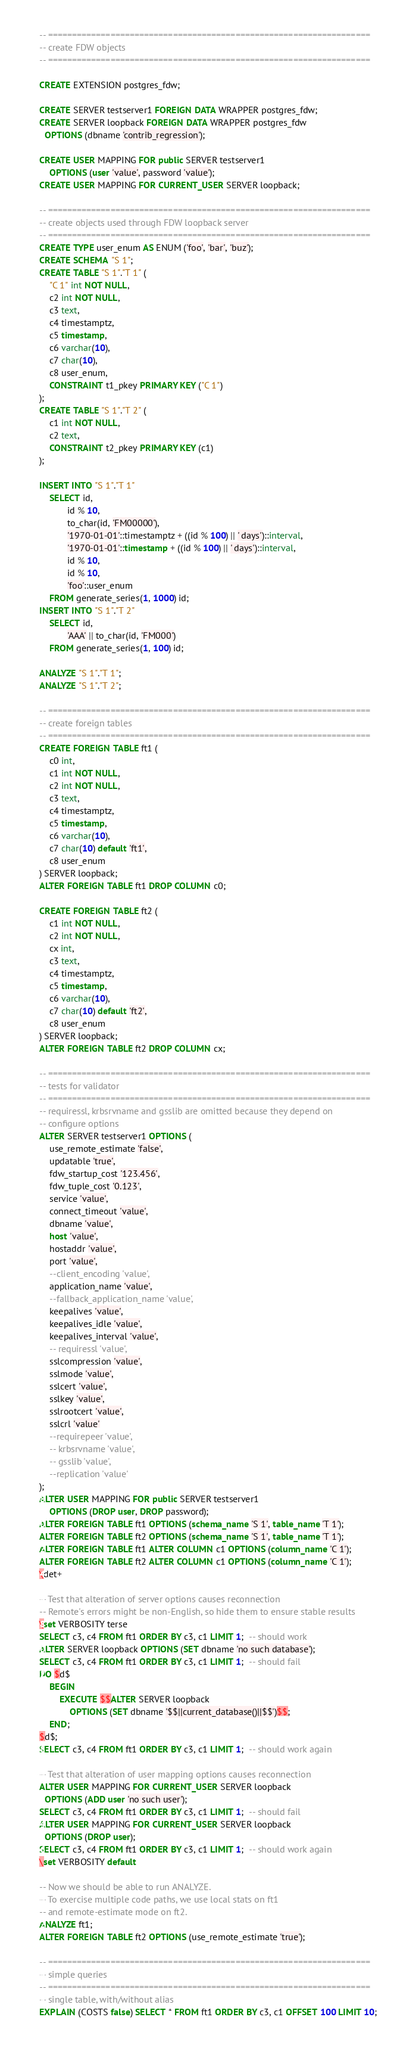Convert code to text. <code><loc_0><loc_0><loc_500><loc_500><_SQL_>-- ===================================================================
-- create FDW objects
-- ===================================================================

CREATE EXTENSION postgres_fdw;

CREATE SERVER testserver1 FOREIGN DATA WRAPPER postgres_fdw;
CREATE SERVER loopback FOREIGN DATA WRAPPER postgres_fdw
  OPTIONS (dbname 'contrib_regression');

CREATE USER MAPPING FOR public SERVER testserver1
	OPTIONS (user 'value', password 'value');
CREATE USER MAPPING FOR CURRENT_USER SERVER loopback;

-- ===================================================================
-- create objects used through FDW loopback server
-- ===================================================================
CREATE TYPE user_enum AS ENUM ('foo', 'bar', 'buz');
CREATE SCHEMA "S 1";
CREATE TABLE "S 1"."T 1" (
	"C 1" int NOT NULL,
	c2 int NOT NULL,
	c3 text,
	c4 timestamptz,
	c5 timestamp,
	c6 varchar(10),
	c7 char(10),
	c8 user_enum,
	CONSTRAINT t1_pkey PRIMARY KEY ("C 1")
);
CREATE TABLE "S 1"."T 2" (
	c1 int NOT NULL,
	c2 text,
	CONSTRAINT t2_pkey PRIMARY KEY (c1)
);

INSERT INTO "S 1"."T 1"
	SELECT id,
	       id % 10,
	       to_char(id, 'FM00000'),
	       '1970-01-01'::timestamptz + ((id % 100) || ' days')::interval,
	       '1970-01-01'::timestamp + ((id % 100) || ' days')::interval,
	       id % 10,
	       id % 10,
	       'foo'::user_enum
	FROM generate_series(1, 1000) id;
INSERT INTO "S 1"."T 2"
	SELECT id,
	       'AAA' || to_char(id, 'FM000')
	FROM generate_series(1, 100) id;

ANALYZE "S 1"."T 1";
ANALYZE "S 1"."T 2";

-- ===================================================================
-- create foreign tables
-- ===================================================================
CREATE FOREIGN TABLE ft1 (
	c0 int,
	c1 int NOT NULL,
	c2 int NOT NULL,
	c3 text,
	c4 timestamptz,
	c5 timestamp,
	c6 varchar(10),
	c7 char(10) default 'ft1',
	c8 user_enum
) SERVER loopback;
ALTER FOREIGN TABLE ft1 DROP COLUMN c0;

CREATE FOREIGN TABLE ft2 (
	c1 int NOT NULL,
	c2 int NOT NULL,
	cx int,
	c3 text,
	c4 timestamptz,
	c5 timestamp,
	c6 varchar(10),
	c7 char(10) default 'ft2',
	c8 user_enum
) SERVER loopback;
ALTER FOREIGN TABLE ft2 DROP COLUMN cx;

-- ===================================================================
-- tests for validator
-- ===================================================================
-- requiressl, krbsrvname and gsslib are omitted because they depend on
-- configure options
ALTER SERVER testserver1 OPTIONS (
	use_remote_estimate 'false',
	updatable 'true',
	fdw_startup_cost '123.456',
	fdw_tuple_cost '0.123',
	service 'value',
	connect_timeout 'value',
	dbname 'value',
	host 'value',
	hostaddr 'value',
	port 'value',
	--client_encoding 'value',
	application_name 'value',
	--fallback_application_name 'value',
	keepalives 'value',
	keepalives_idle 'value',
	keepalives_interval 'value',
	-- requiressl 'value',
	sslcompression 'value',
	sslmode 'value',
	sslcert 'value',
	sslkey 'value',
	sslrootcert 'value',
	sslcrl 'value'
	--requirepeer 'value',
	-- krbsrvname 'value',
	-- gsslib 'value',
	--replication 'value'
);
ALTER USER MAPPING FOR public SERVER testserver1
	OPTIONS (DROP user, DROP password);
ALTER FOREIGN TABLE ft1 OPTIONS (schema_name 'S 1', table_name 'T 1');
ALTER FOREIGN TABLE ft2 OPTIONS (schema_name 'S 1', table_name 'T 1');
ALTER FOREIGN TABLE ft1 ALTER COLUMN c1 OPTIONS (column_name 'C 1');
ALTER FOREIGN TABLE ft2 ALTER COLUMN c1 OPTIONS (column_name 'C 1');
\det+

-- Test that alteration of server options causes reconnection
-- Remote's errors might be non-English, so hide them to ensure stable results
\set VERBOSITY terse
SELECT c3, c4 FROM ft1 ORDER BY c3, c1 LIMIT 1;  -- should work
ALTER SERVER loopback OPTIONS (SET dbname 'no such database');
SELECT c3, c4 FROM ft1 ORDER BY c3, c1 LIMIT 1;  -- should fail
DO $d$
    BEGIN
        EXECUTE $$ALTER SERVER loopback
            OPTIONS (SET dbname '$$||current_database()||$$')$$;
    END;
$d$;
SELECT c3, c4 FROM ft1 ORDER BY c3, c1 LIMIT 1;  -- should work again

-- Test that alteration of user mapping options causes reconnection
ALTER USER MAPPING FOR CURRENT_USER SERVER loopback
  OPTIONS (ADD user 'no such user');
SELECT c3, c4 FROM ft1 ORDER BY c3, c1 LIMIT 1;  -- should fail
ALTER USER MAPPING FOR CURRENT_USER SERVER loopback
  OPTIONS (DROP user);
SELECT c3, c4 FROM ft1 ORDER BY c3, c1 LIMIT 1;  -- should work again
\set VERBOSITY default

-- Now we should be able to run ANALYZE.
-- To exercise multiple code paths, we use local stats on ft1
-- and remote-estimate mode on ft2.
ANALYZE ft1;
ALTER FOREIGN TABLE ft2 OPTIONS (use_remote_estimate 'true');

-- ===================================================================
-- simple queries
-- ===================================================================
-- single table, with/without alias
EXPLAIN (COSTS false) SELECT * FROM ft1 ORDER BY c3, c1 OFFSET 100 LIMIT 10;</code> 